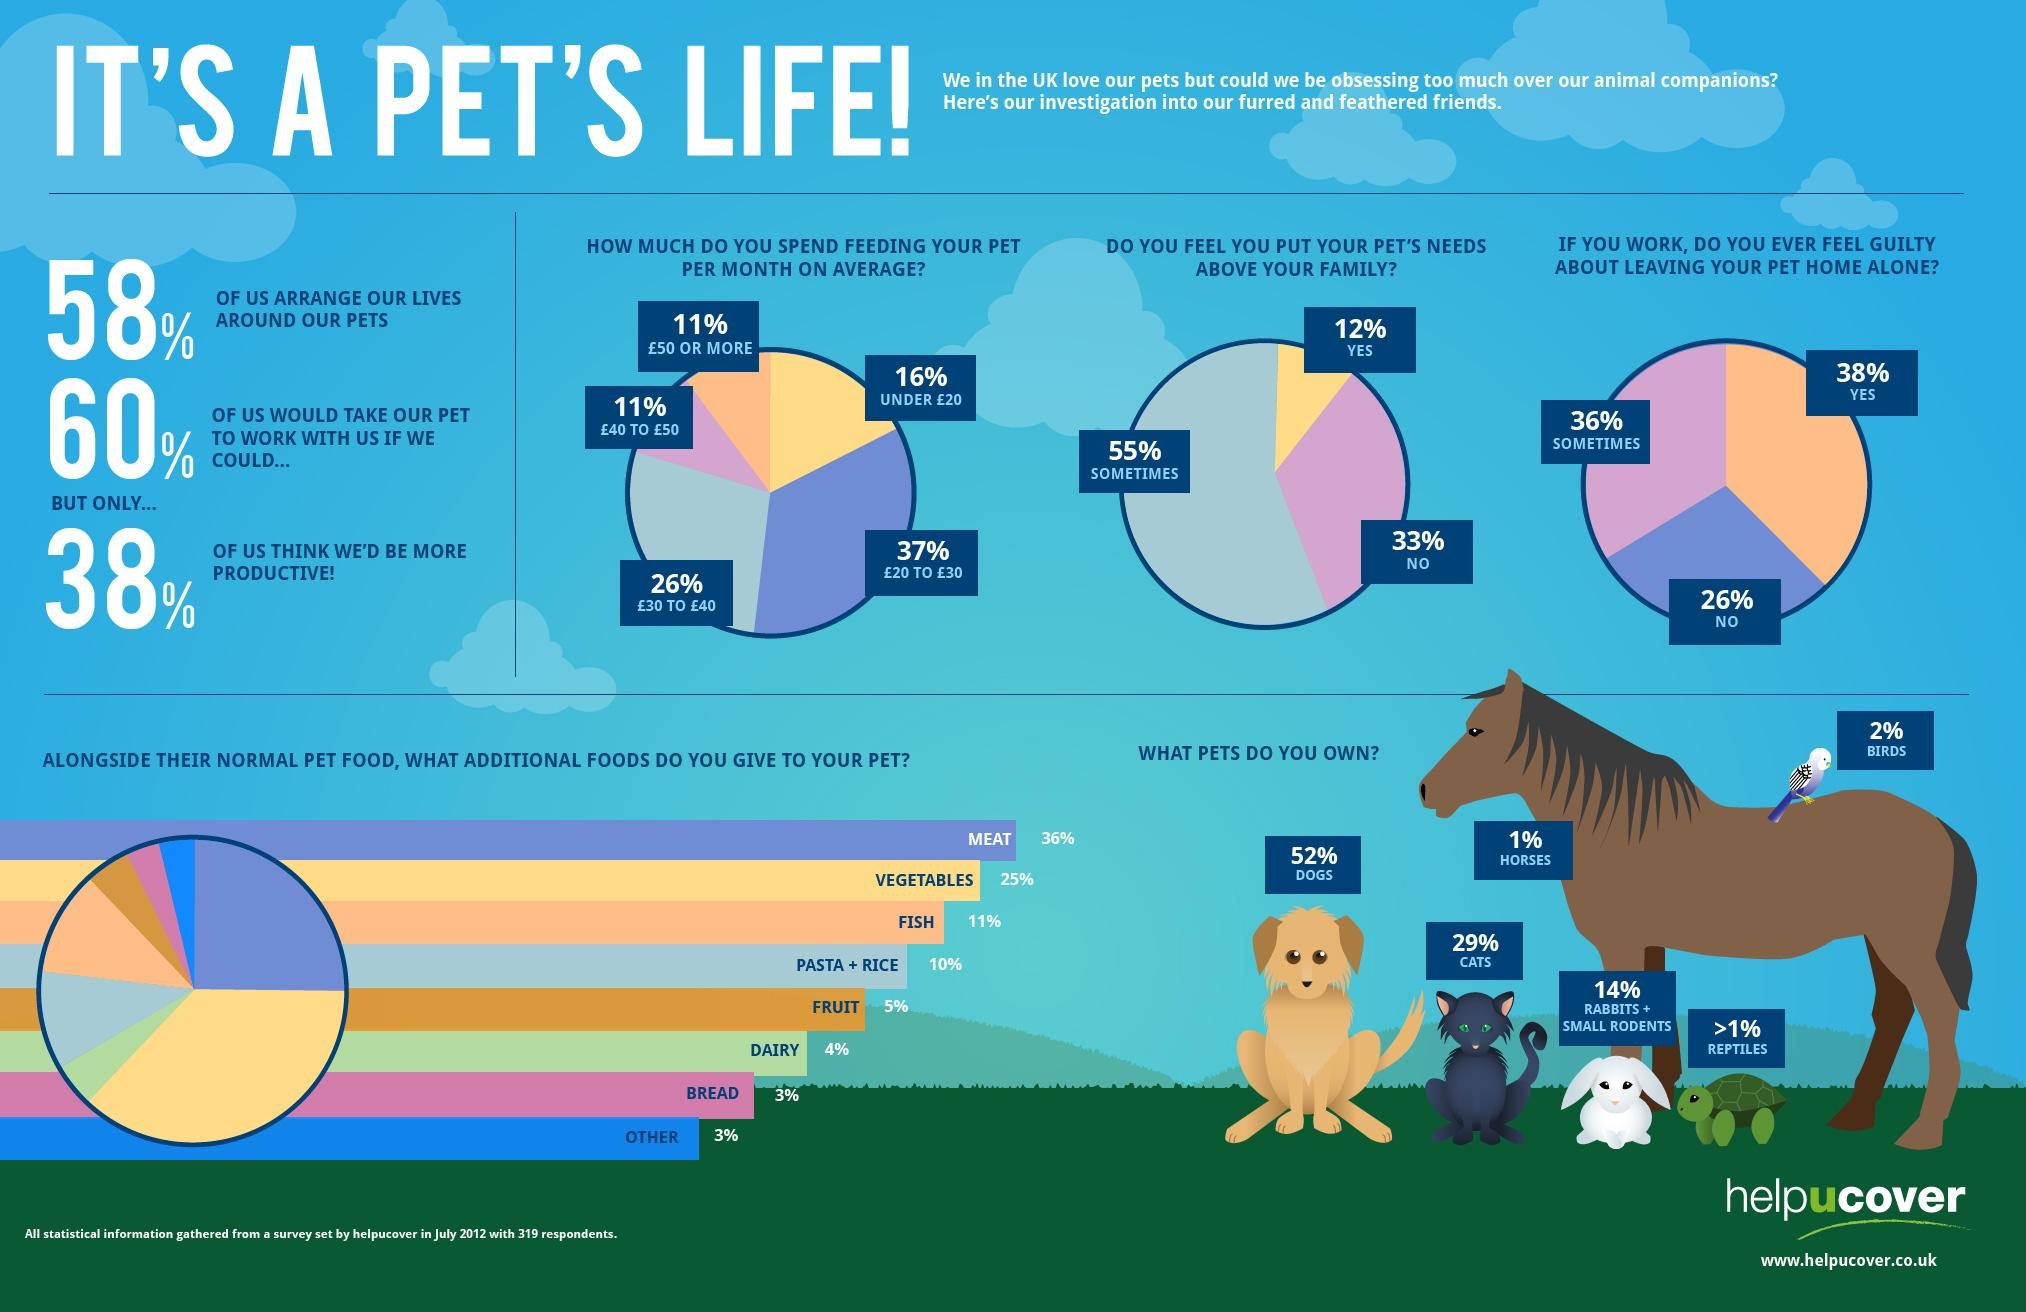Draw attention to some important aspects in this diagram. According to a recent survey, 12% of pet owners indicate that they always prioritize their pets above their family. According to the survey, 26% of pet owners do not feel guilty about leaving their pets alone at home. According to a survey, a majority of pet owners, specifically dogs, own 52% of all pets. Horses, birds, and reptiles are all animals that can be kept as pets. However, according to popularity, birds are the most commonly kept as pets. According to a survey, only 1% of pet owners own horses. 